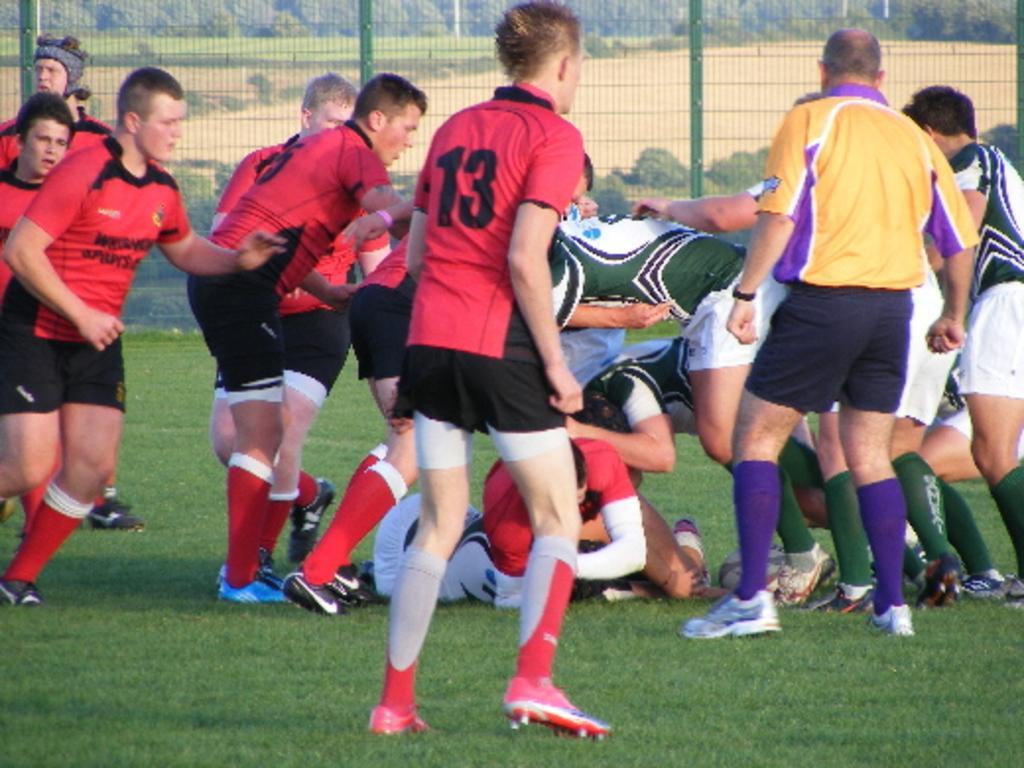How would you summarize this image in a sentence or two? In the foreground of this image, there are men few are standing on the grass and a man is lying on it. In the background, there is fencing. Behind fencing, there are trees and the ground. 